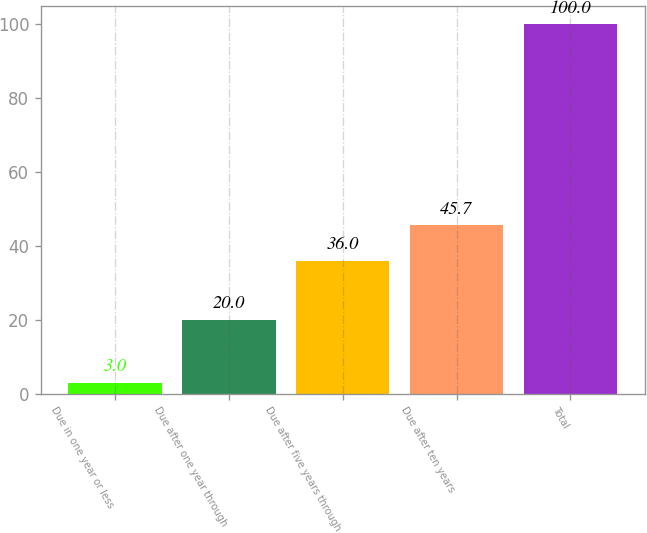<chart> <loc_0><loc_0><loc_500><loc_500><bar_chart><fcel>Due in one year or less<fcel>Due after one year through<fcel>Due after five years through<fcel>Due after ten years<fcel>Total<nl><fcel>3<fcel>20<fcel>36<fcel>45.7<fcel>100<nl></chart> 